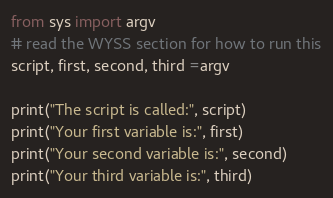<code> <loc_0><loc_0><loc_500><loc_500><_Python_>from sys import argv
# read the WYSS section for how to run this
script, first, second, third =argv

print("The script is called:", script)
print("Your first variable is:", first)
print("Your second variable is:", second)
print("Your third variable is:", third)
</code> 